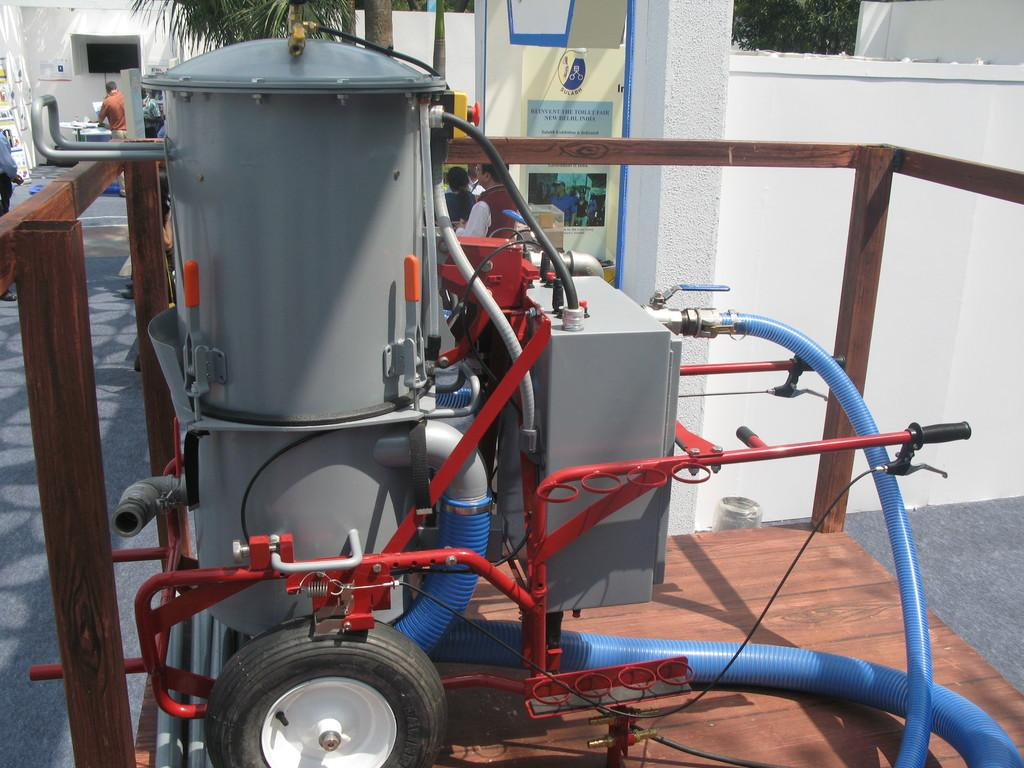What is located on the left side of the image? There is a machine on the left side of the image. What can be seen at the top side of the image? There is a poster at the top side of the image. Are there any people visible in the image? Yes, there are people in the top left side of the image. What type of toothpaste is being advertised on the poster in the image? There is no toothpaste or advertisement present on the poster in the image. Can you describe the veins of the people in the image? There is no reference to veins or any medical information about the people in the image. 